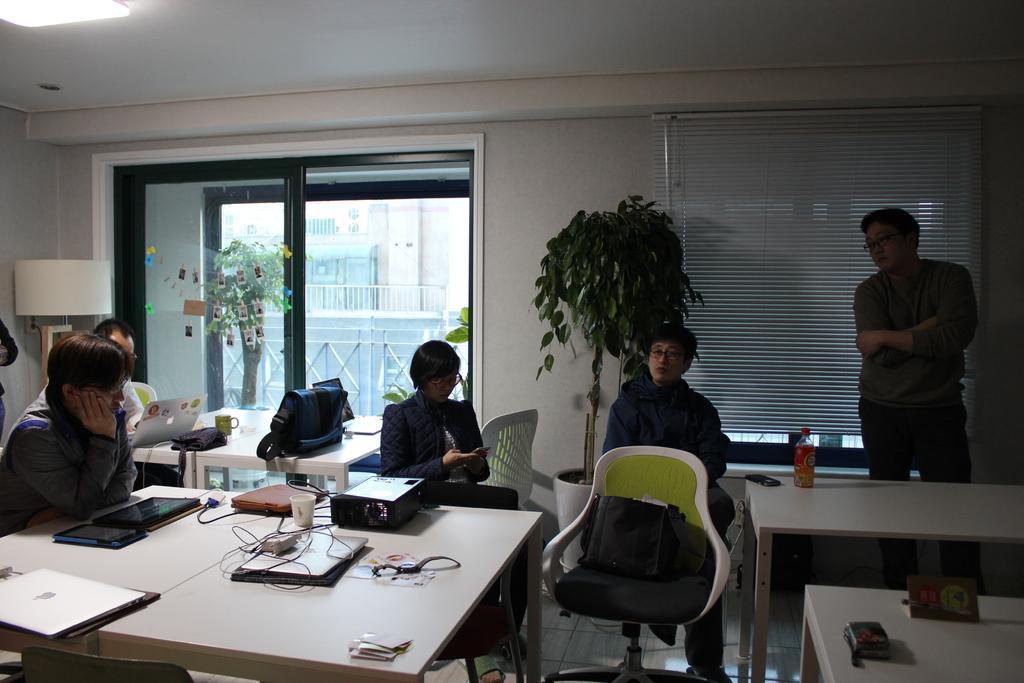In one or two sentences, can you explain what this image depicts? This is a inside picture of a room. In the center of the image there is a table on which there are many objects. There are people sitting on chairs. There is a plant. In the background of the image there is a wall. There is a glass door. At the right side of the image there is a person standing. 